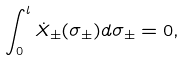Convert formula to latex. <formula><loc_0><loc_0><loc_500><loc_500>\int _ { 0 } ^ { l } { \dot { X } _ { \pm } } ( \sigma _ { \pm } ) d \sigma _ { \pm } = 0 ,</formula> 